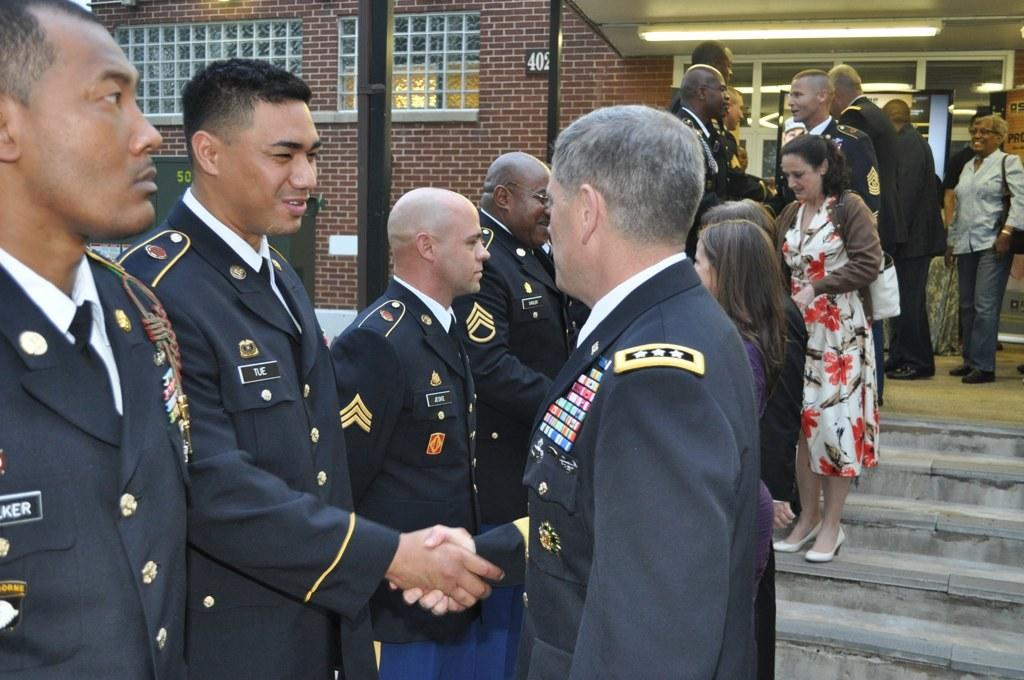How many men are standing on the left side of the image? There are four men standing on the left side of the image. What are the men wearing in the image? The men are wearing coats in the image. Where are the women located in the image? The women are standing on the right side of the image. What is the women's position in relation to the staircases? The women are on staircases in the image. What type of vegetable is being used as a division on the staircases? There is no vegetable present in the image, nor is there any division on the staircases. 